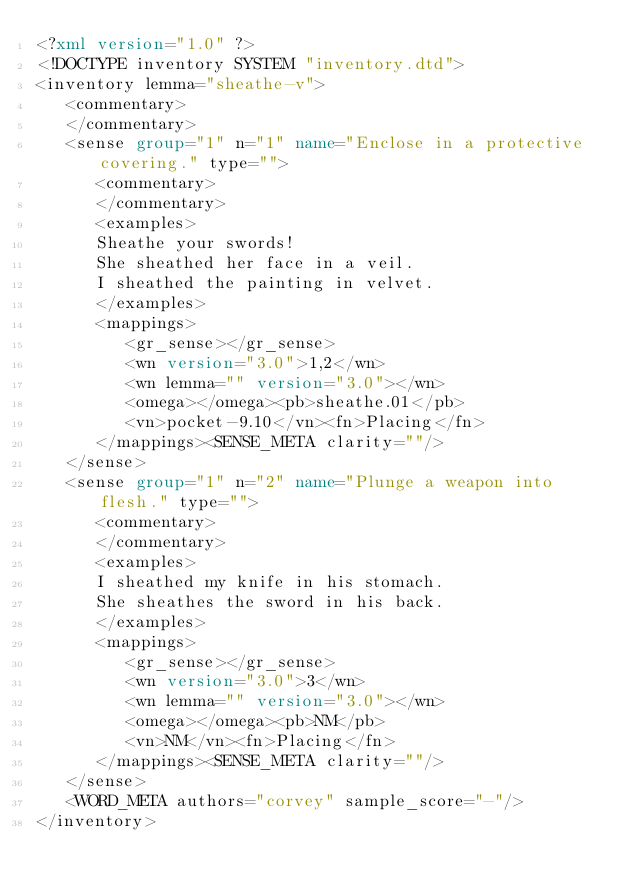<code> <loc_0><loc_0><loc_500><loc_500><_XML_><?xml version="1.0" ?>
<!DOCTYPE inventory SYSTEM "inventory.dtd">
<inventory lemma="sheathe-v">    
   <commentary>
   </commentary>
   <sense group="1" n="1" name="Enclose in a protective covering." type="">  
      <commentary>
      </commentary>
      <examples>
      Sheathe your swords!
      She sheathed her face in a veil.
      I sheathed the painting in velvet.
      </examples>
      <mappings>
         <gr_sense></gr_sense>
         <wn version="3.0">1,2</wn>   
         <wn lemma="" version="3.0"></wn>
         <omega></omega><pb>sheathe.01</pb>
         <vn>pocket-9.10</vn><fn>Placing</fn>
      </mappings><SENSE_META clarity=""/>
   </sense>
   <sense group="1" n="2" name="Plunge a weapon into flesh." type="">
      <commentary>
      </commentary>
      <examples> 
      I sheathed my knife in his stomach.
      She sheathes the sword in his back.
      </examples>
      <mappings>
         <gr_sense></gr_sense>
         <wn version="3.0">3</wn>
         <wn lemma="" version="3.0"></wn>
         <omega></omega><pb>NM</pb>
         <vn>NM</vn><fn>Placing</fn>
      </mappings><SENSE_META clarity=""/>
   </sense>
   <WORD_META authors="corvey" sample_score="-"/>  
</inventory>
</code> 